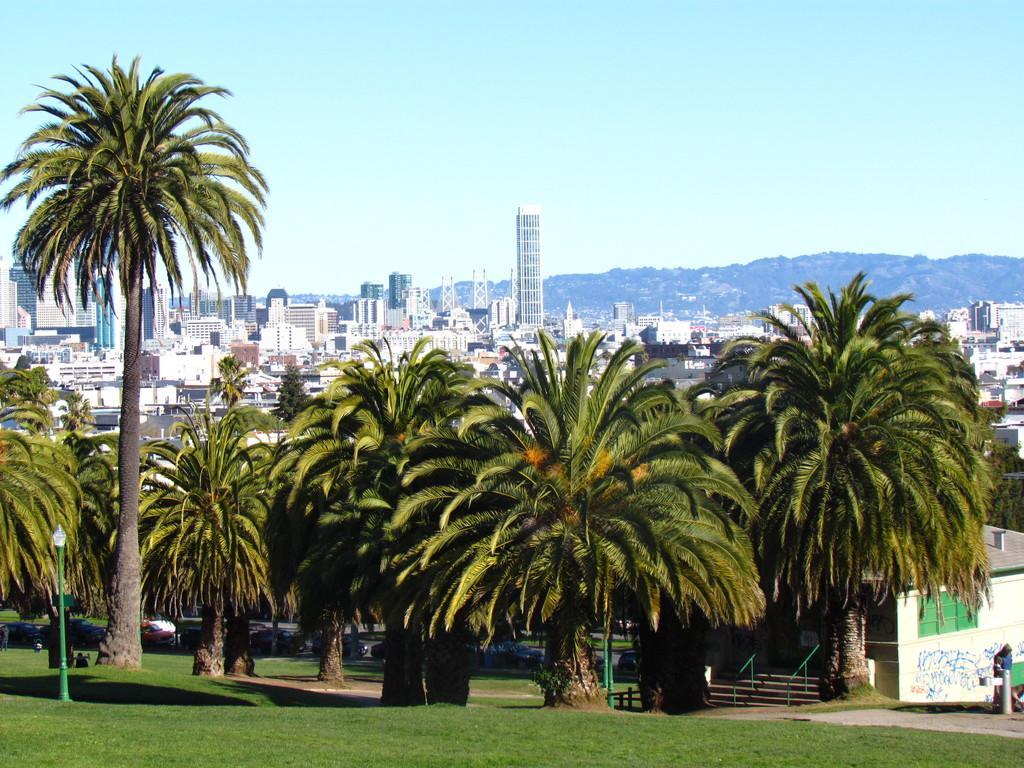Describe this image in one or two sentences. In the foreground I can see grass, poles and trees. In the background I can see buildings, towers and mountains. On the top I can see the blue sky. This image is taken during a day. 